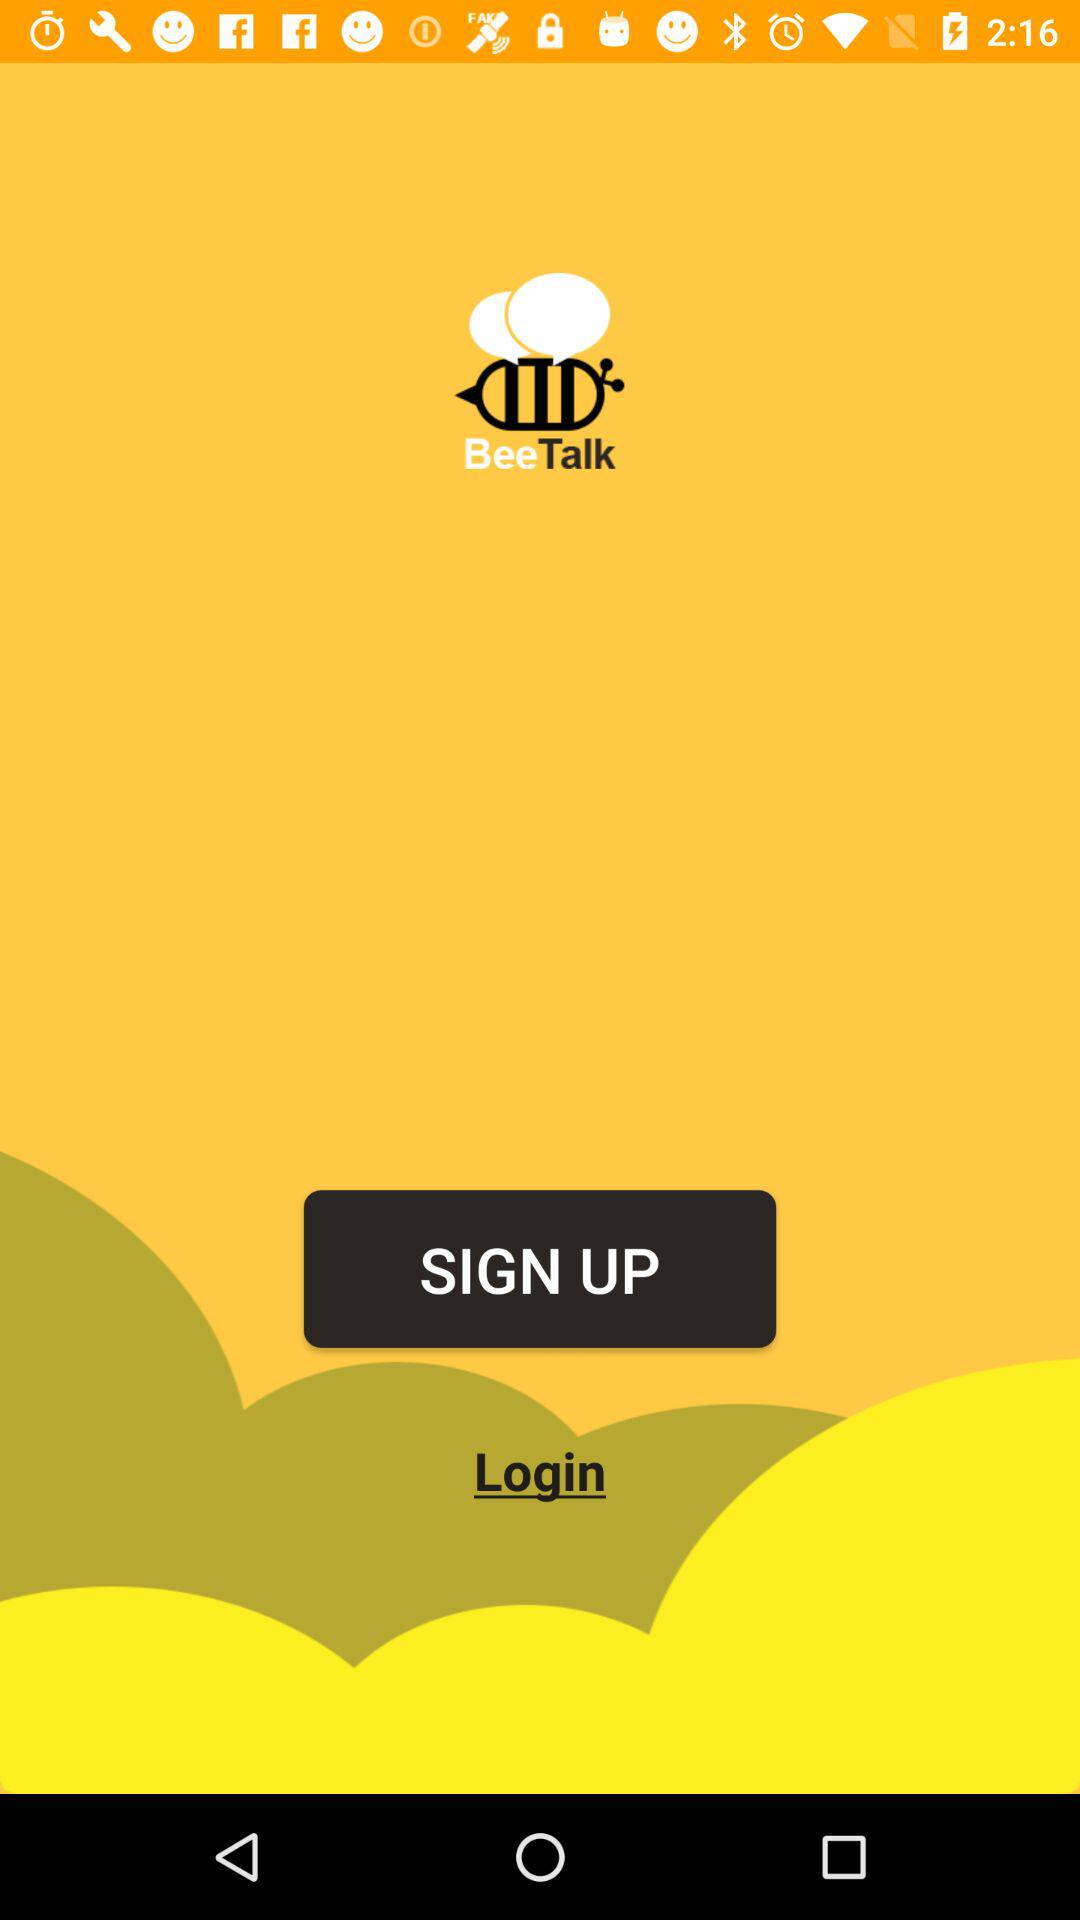What is the version of this application?
When the provided information is insufficient, respond with <no answer>. <no answer> 